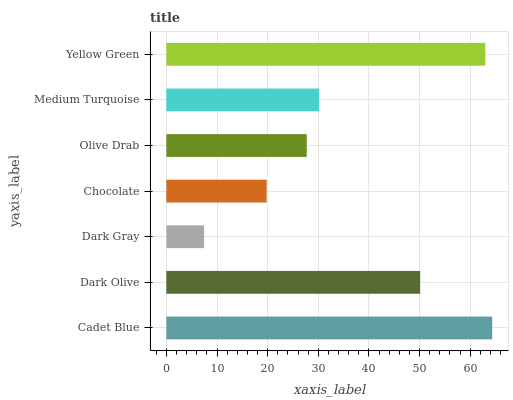Is Dark Gray the minimum?
Answer yes or no. Yes. Is Cadet Blue the maximum?
Answer yes or no. Yes. Is Dark Olive the minimum?
Answer yes or no. No. Is Dark Olive the maximum?
Answer yes or no. No. Is Cadet Blue greater than Dark Olive?
Answer yes or no. Yes. Is Dark Olive less than Cadet Blue?
Answer yes or no. Yes. Is Dark Olive greater than Cadet Blue?
Answer yes or no. No. Is Cadet Blue less than Dark Olive?
Answer yes or no. No. Is Medium Turquoise the high median?
Answer yes or no. Yes. Is Medium Turquoise the low median?
Answer yes or no. Yes. Is Olive Drab the high median?
Answer yes or no. No. Is Yellow Green the low median?
Answer yes or no. No. 